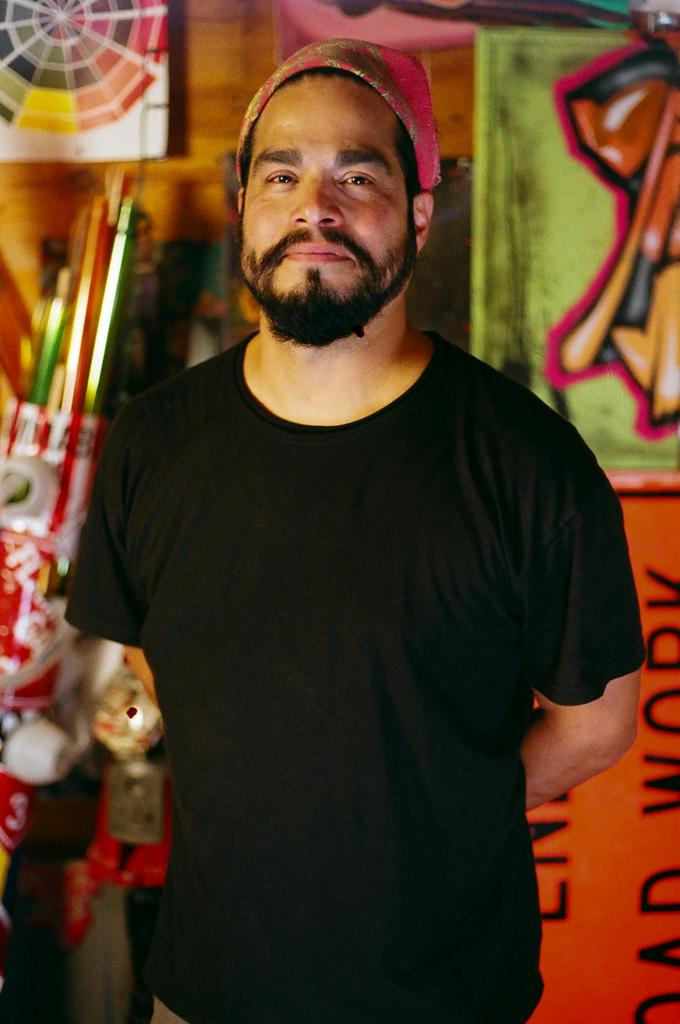Who is in the image? There is a person in the image. What is the person wearing on their upper body? The person is wearing a black t-shirt. What type of headwear is the person wearing? The person is wearing a cap. What is the person's posture in the image? The person is standing. What can be seen in the background of the image? There is a dartboard and a group of poles in the background of the image. What type of jewel is the person wearing on their skirt in the image? There is no skirt or jewel present in the image; the person is wearing a black t-shirt and a cap. 